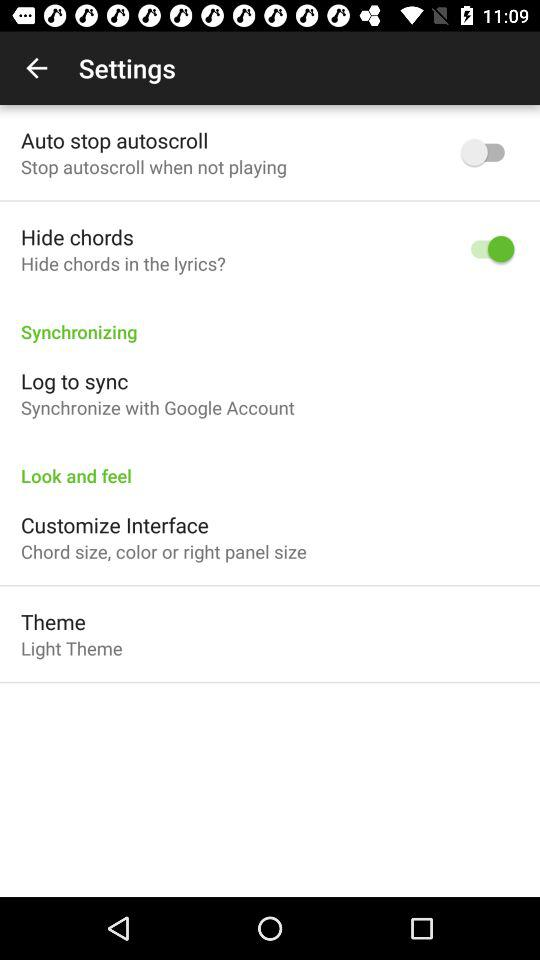Which option has been switched on? The option "Hide chords" has been switched on. 